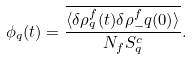<formula> <loc_0><loc_0><loc_500><loc_500>\phi _ { q } ( t ) = \frac { \overline { \langle \delta \rho ^ { f } _ { q } ( t ) \delta \rho ^ { f } _ { - } q ( 0 ) \rangle } } { N _ { f } S ^ { c } _ { q } } .</formula> 